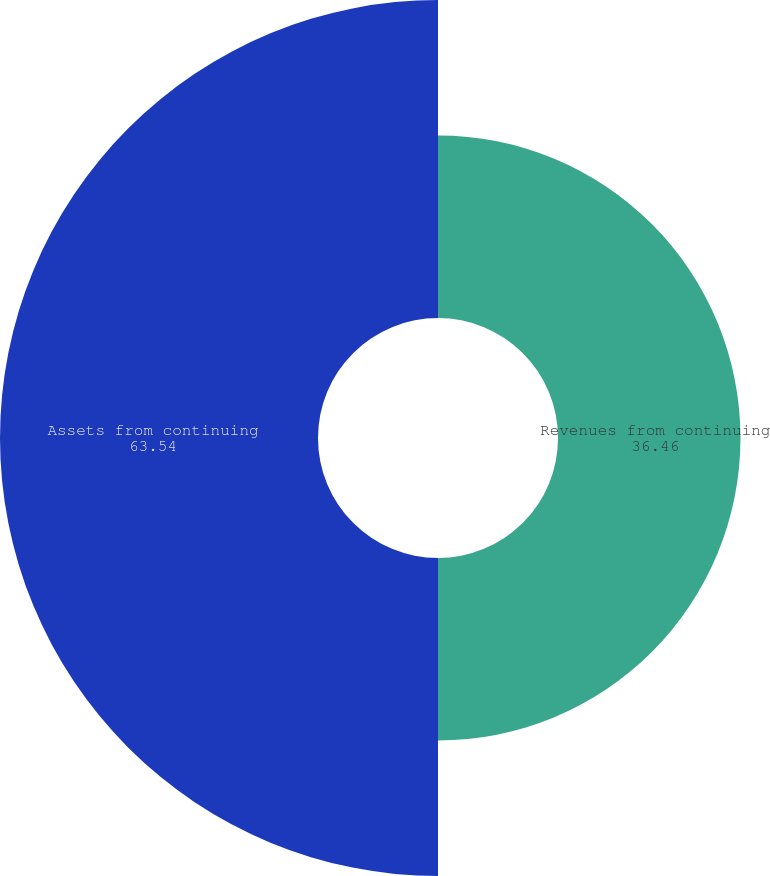Convert chart. <chart><loc_0><loc_0><loc_500><loc_500><pie_chart><fcel>Revenues from continuing<fcel>Assets from continuing<nl><fcel>36.46%<fcel>63.54%<nl></chart> 